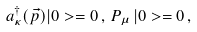<formula> <loc_0><loc_0><loc_500><loc_500>a _ { \kappa } ^ { \dag } ( \vec { p } ) | 0 > = 0 \, , \, P _ { \mu } \, | 0 > = 0 \, ,</formula> 